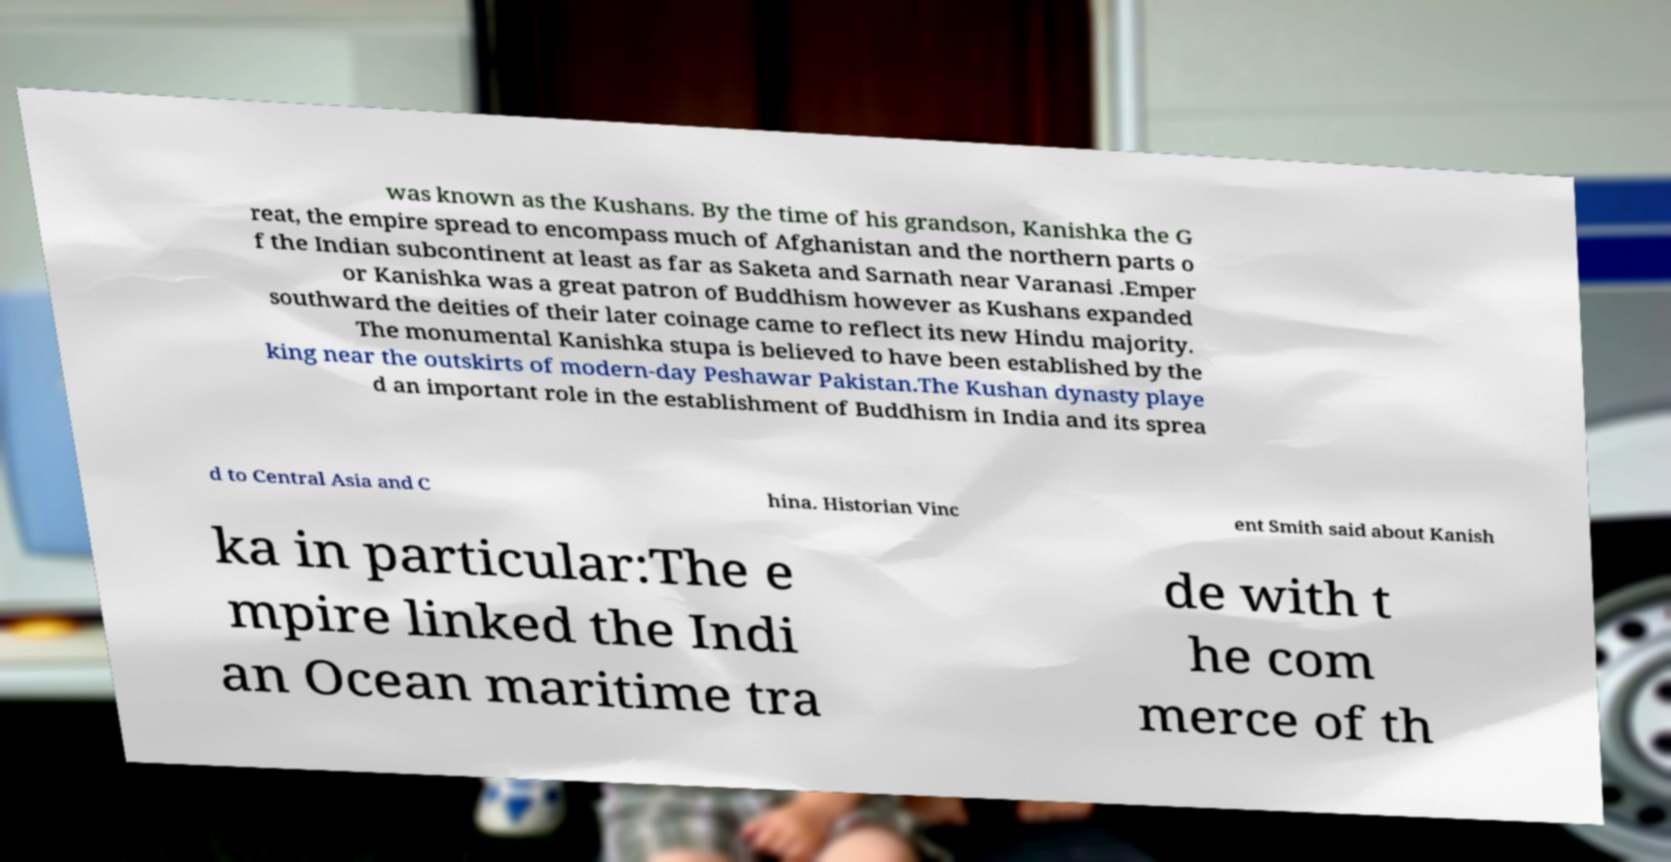Can you accurately transcribe the text from the provided image for me? was known as the Kushans. By the time of his grandson, Kanishka the G reat, the empire spread to encompass much of Afghanistan and the northern parts o f the Indian subcontinent at least as far as Saketa and Sarnath near Varanasi .Emper or Kanishka was a great patron of Buddhism however as Kushans expanded southward the deities of their later coinage came to reflect its new Hindu majority. The monumental Kanishka stupa is believed to have been established by the king near the outskirts of modern-day Peshawar Pakistan.The Kushan dynasty playe d an important role in the establishment of Buddhism in India and its sprea d to Central Asia and C hina. Historian Vinc ent Smith said about Kanish ka in particular:The e mpire linked the Indi an Ocean maritime tra de with t he com merce of th 